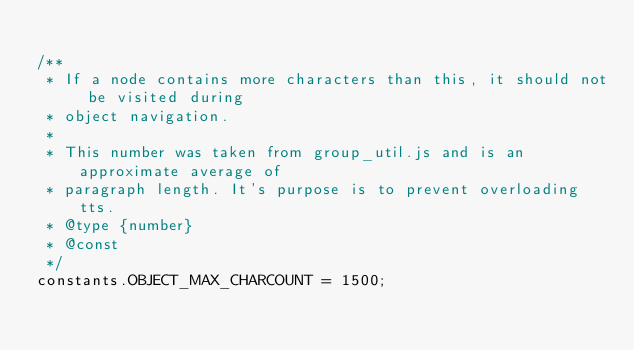Convert code to text. <code><loc_0><loc_0><loc_500><loc_500><_JavaScript_>
/**
 * If a node contains more characters than this, it should not be visited during
 * object navigation.
 *
 * This number was taken from group_util.js and is an approximate average of
 * paragraph length. It's purpose is to prevent overloading tts.
 * @type {number}
 * @const
 */
constants.OBJECT_MAX_CHARCOUNT = 1500;
</code> 